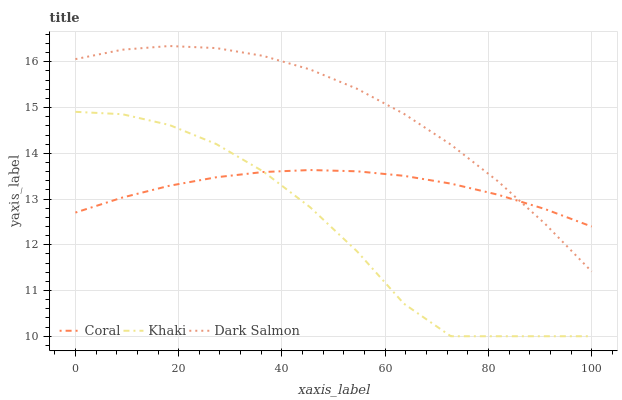Does Khaki have the minimum area under the curve?
Answer yes or no. Yes. Does Dark Salmon have the maximum area under the curve?
Answer yes or no. Yes. Does Dark Salmon have the minimum area under the curve?
Answer yes or no. No. Does Khaki have the maximum area under the curve?
Answer yes or no. No. Is Coral the smoothest?
Answer yes or no. Yes. Is Khaki the roughest?
Answer yes or no. Yes. Is Dark Salmon the smoothest?
Answer yes or no. No. Is Dark Salmon the roughest?
Answer yes or no. No. Does Khaki have the lowest value?
Answer yes or no. Yes. Does Dark Salmon have the lowest value?
Answer yes or no. No. Does Dark Salmon have the highest value?
Answer yes or no. Yes. Does Khaki have the highest value?
Answer yes or no. No. Is Khaki less than Dark Salmon?
Answer yes or no. Yes. Is Dark Salmon greater than Khaki?
Answer yes or no. Yes. Does Coral intersect Khaki?
Answer yes or no. Yes. Is Coral less than Khaki?
Answer yes or no. No. Is Coral greater than Khaki?
Answer yes or no. No. Does Khaki intersect Dark Salmon?
Answer yes or no. No. 